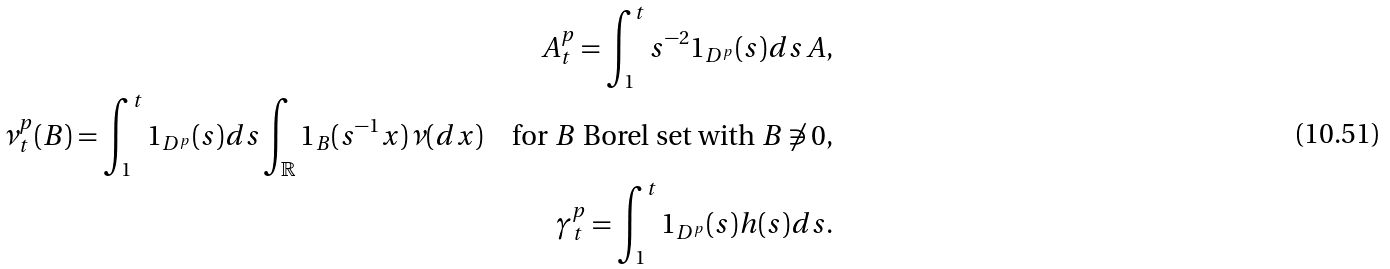<formula> <loc_0><loc_0><loc_500><loc_500>A _ { t } ^ { p } = \int _ { 1 } ^ { t } s ^ { - 2 } 1 _ { D ^ { p } } ( s ) d s \, A , \\ \nu _ { t } ^ { p } ( B ) = \int _ { 1 } ^ { t } 1 _ { D ^ { p } } ( s ) d s \int _ { \mathbb { R } } 1 _ { B } ( s ^ { - 1 } x ) \nu ( d x ) \quad \text {for $B$ Borel set with $B\not\ni0$} , \\ \gamma _ { t } ^ { p } = \int _ { 1 } ^ { t } 1 _ { D ^ { p } } ( s ) h ( s ) d s .</formula> 